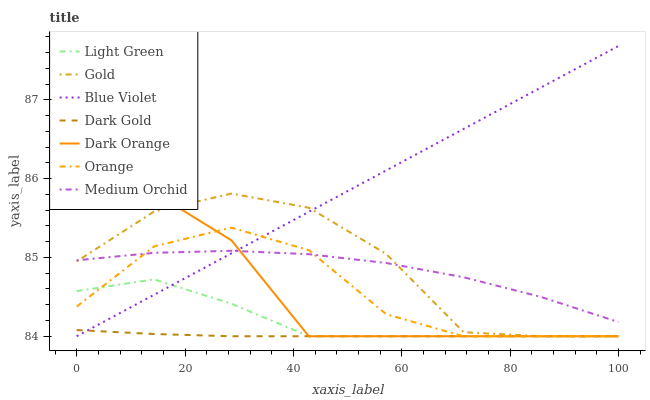Does Dark Gold have the minimum area under the curve?
Answer yes or no. Yes. Does Blue Violet have the maximum area under the curve?
Answer yes or no. Yes. Does Gold have the minimum area under the curve?
Answer yes or no. No. Does Gold have the maximum area under the curve?
Answer yes or no. No. Is Blue Violet the smoothest?
Answer yes or no. Yes. Is Gold the roughest?
Answer yes or no. Yes. Is Dark Gold the smoothest?
Answer yes or no. No. Is Dark Gold the roughest?
Answer yes or no. No. Does Dark Orange have the lowest value?
Answer yes or no. Yes. Does Medium Orchid have the lowest value?
Answer yes or no. No. Does Blue Violet have the highest value?
Answer yes or no. Yes. Does Gold have the highest value?
Answer yes or no. No. Is Dark Gold less than Medium Orchid?
Answer yes or no. Yes. Is Medium Orchid greater than Light Green?
Answer yes or no. Yes. Does Light Green intersect Orange?
Answer yes or no. Yes. Is Light Green less than Orange?
Answer yes or no. No. Is Light Green greater than Orange?
Answer yes or no. No. Does Dark Gold intersect Medium Orchid?
Answer yes or no. No. 